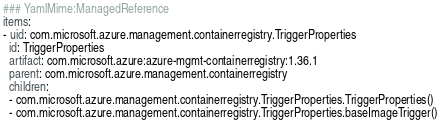Convert code to text. <code><loc_0><loc_0><loc_500><loc_500><_YAML_>### YamlMime:ManagedReference
items:
- uid: com.microsoft.azure.management.containerregistry.TriggerProperties
  id: TriggerProperties
  artifact: com.microsoft.azure:azure-mgmt-containerregistry:1.36.1
  parent: com.microsoft.azure.management.containerregistry
  children:
  - com.microsoft.azure.management.containerregistry.TriggerProperties.TriggerProperties()
  - com.microsoft.azure.management.containerregistry.TriggerProperties.baseImageTrigger()</code> 